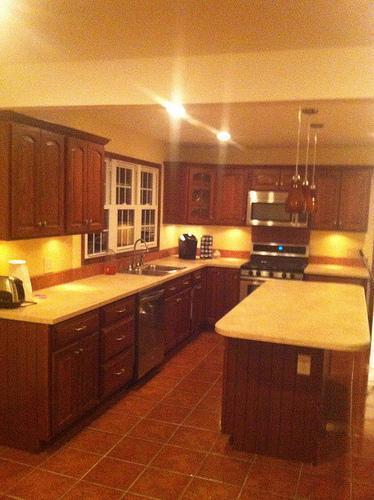How many stoves are there?
Give a very brief answer. 1. 